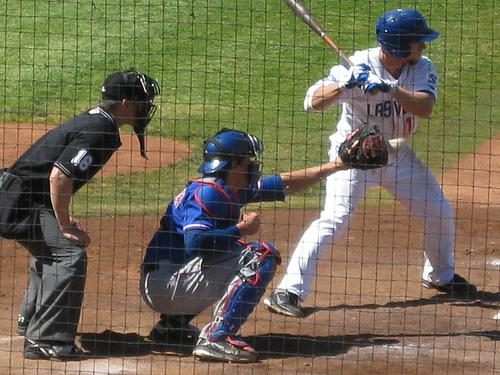Question: who is behind the plate?
Choices:
A. Catcher.
B. Umpire.
C. Batter.
D. Fans.
Answer with the letter. Answer: A Question: what color is the batter's helmet?
Choices:
A. Blue.
B. Red.
C. Black.
D. Brown.
Answer with the letter. Answer: A Question: what are the players wearing?
Choices:
A. Uniforms.
B. Jerseys.
C. Pants.
D. Cleats.
Answer with the letter. Answer: A 